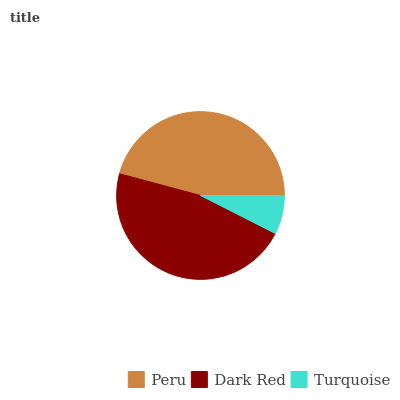Is Turquoise the minimum?
Answer yes or no. Yes. Is Dark Red the maximum?
Answer yes or no. Yes. Is Dark Red the minimum?
Answer yes or no. No. Is Turquoise the maximum?
Answer yes or no. No. Is Dark Red greater than Turquoise?
Answer yes or no. Yes. Is Turquoise less than Dark Red?
Answer yes or no. Yes. Is Turquoise greater than Dark Red?
Answer yes or no. No. Is Dark Red less than Turquoise?
Answer yes or no. No. Is Peru the high median?
Answer yes or no. Yes. Is Peru the low median?
Answer yes or no. Yes. Is Turquoise the high median?
Answer yes or no. No. Is Dark Red the low median?
Answer yes or no. No. 